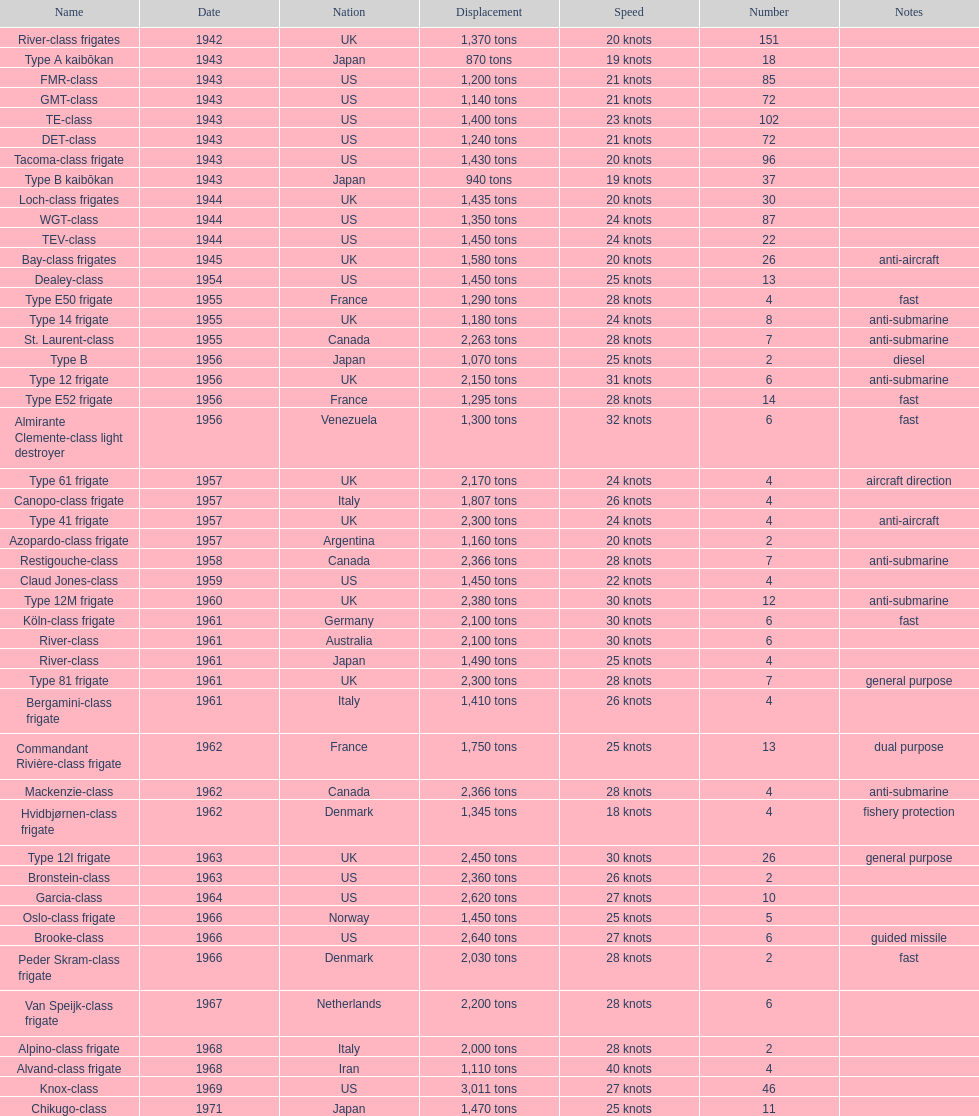In 1968, what was the maximum speed of the alpino-class frigate used by italy? 28 knots. 